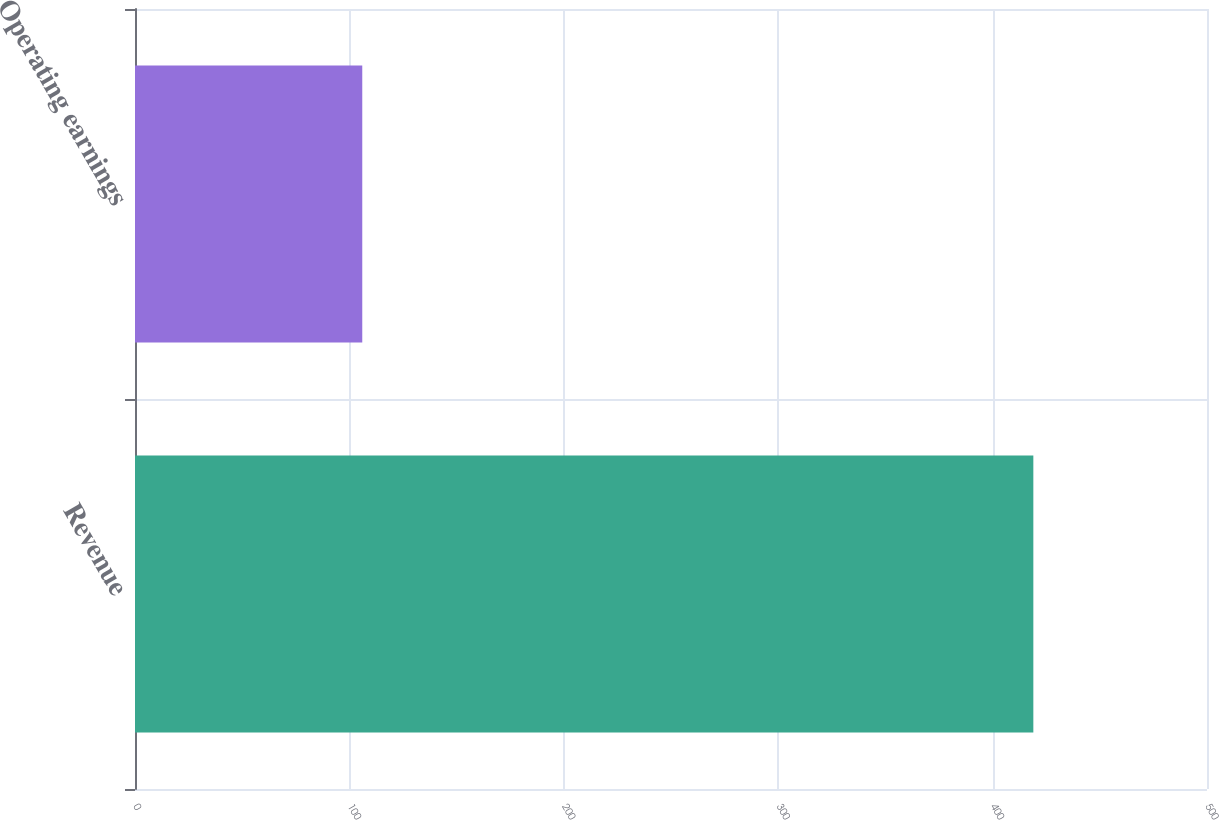Convert chart. <chart><loc_0><loc_0><loc_500><loc_500><bar_chart><fcel>Revenue<fcel>Operating earnings<nl><fcel>419<fcel>106<nl></chart> 